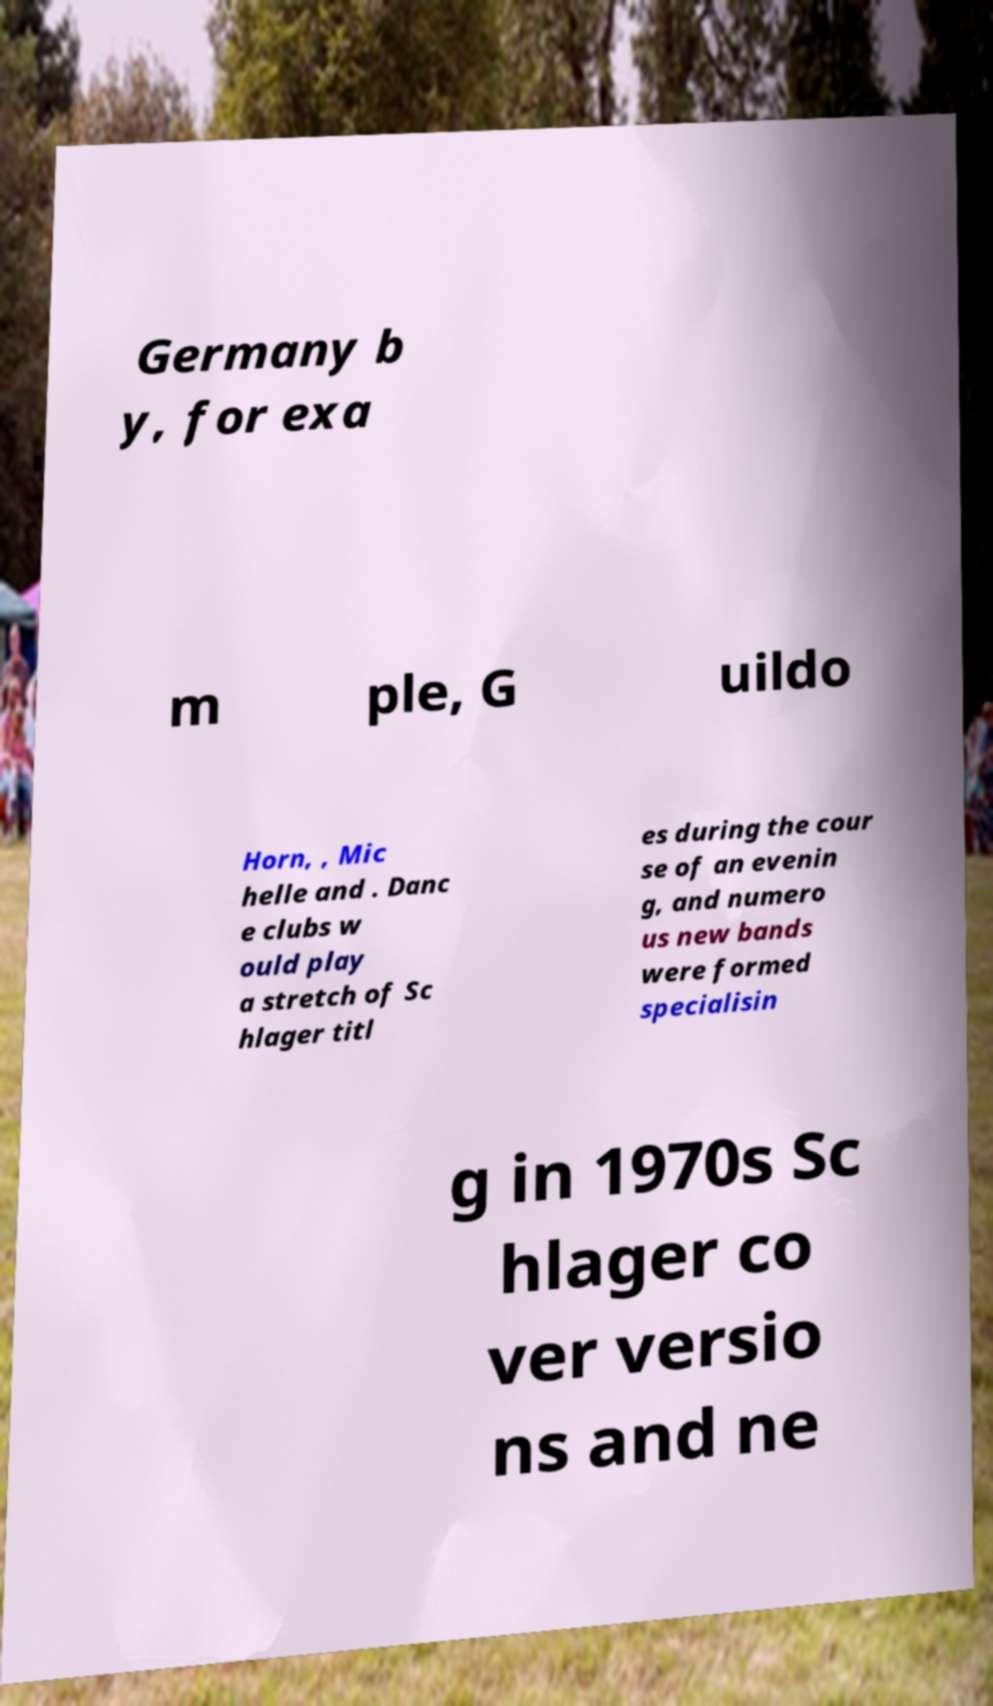Can you read and provide the text displayed in the image?This photo seems to have some interesting text. Can you extract and type it out for me? Germany b y, for exa m ple, G uildo Horn, , Mic helle and . Danc e clubs w ould play a stretch of Sc hlager titl es during the cour se of an evenin g, and numero us new bands were formed specialisin g in 1970s Sc hlager co ver versio ns and ne 